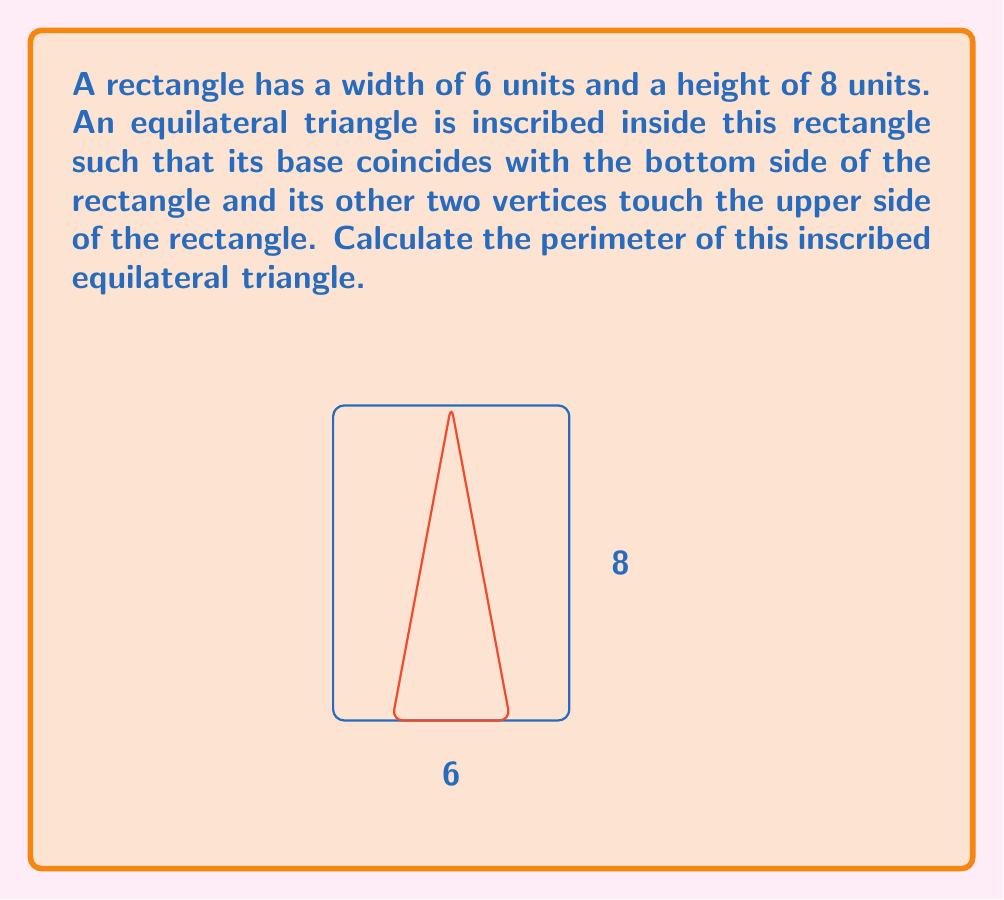Show me your answer to this math problem. Let's approach this step-by-step:

1) In an equilateral triangle, all sides are equal. Let's denote the side length as $s$.

2) The base of the triangle is on the bottom of the rectangle. Its length is the width of the rectangle minus the distances from the left and right sides. Due to symmetry, these distances are equal. Let's call this distance $x$.

   So, $s = 6 - 2x$

3) The height of the equilateral triangle is equal to the height of the rectangle, which is 8.

4) In an equilateral triangle, the height ($h$) is related to the side length ($s$) by the formula:

   $h = \frac{\sqrt{3}}{2}s$

5) Substituting our known values:

   $8 = \frac{\sqrt{3}}{2}(6-2x)$

6) Solving for $x$:

   $16 = \sqrt{3}(6-2x)$
   $\frac{16}{\sqrt{3}} = 6-2x$
   $\frac{16}{\sqrt{3}} - 6 = -2x$
   $x = 3 - \frac{8}{\sqrt{3}}$

7) Now we can find $s$:

   $s = 6 - 2(3 - \frac{8}{\sqrt{3}}) = 6 - 6 + \frac{16}{\sqrt{3}} = \frac{16}{\sqrt{3}}$

8) The perimeter of the triangle is $3s$, so:

   Perimeter $= 3 \cdot \frac{16}{\sqrt{3}} = \frac{48}{\sqrt{3}}$
Answer: $\frac{48}{\sqrt{3}}$ units 